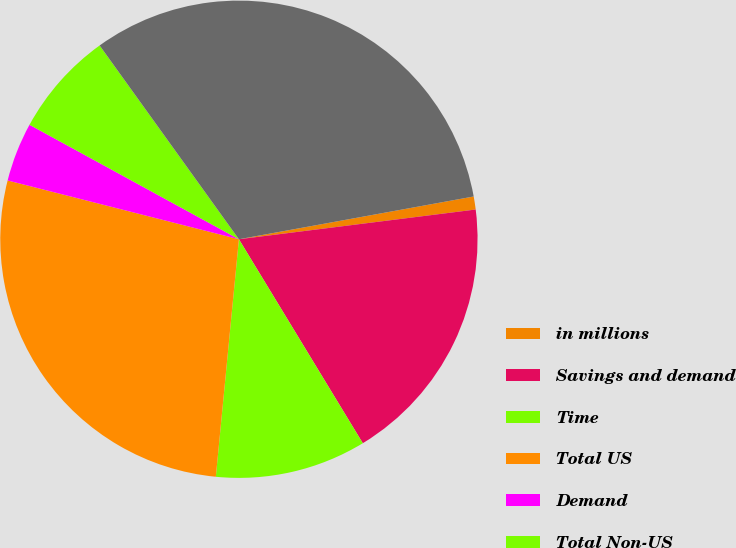Convert chart. <chart><loc_0><loc_0><loc_500><loc_500><pie_chart><fcel>in millions<fcel>Savings and demand<fcel>Time<fcel>Total US<fcel>Demand<fcel>Total Non-US<fcel>Total<nl><fcel>0.88%<fcel>18.3%<fcel>10.23%<fcel>27.42%<fcel>4.0%<fcel>7.12%<fcel>32.05%<nl></chart> 